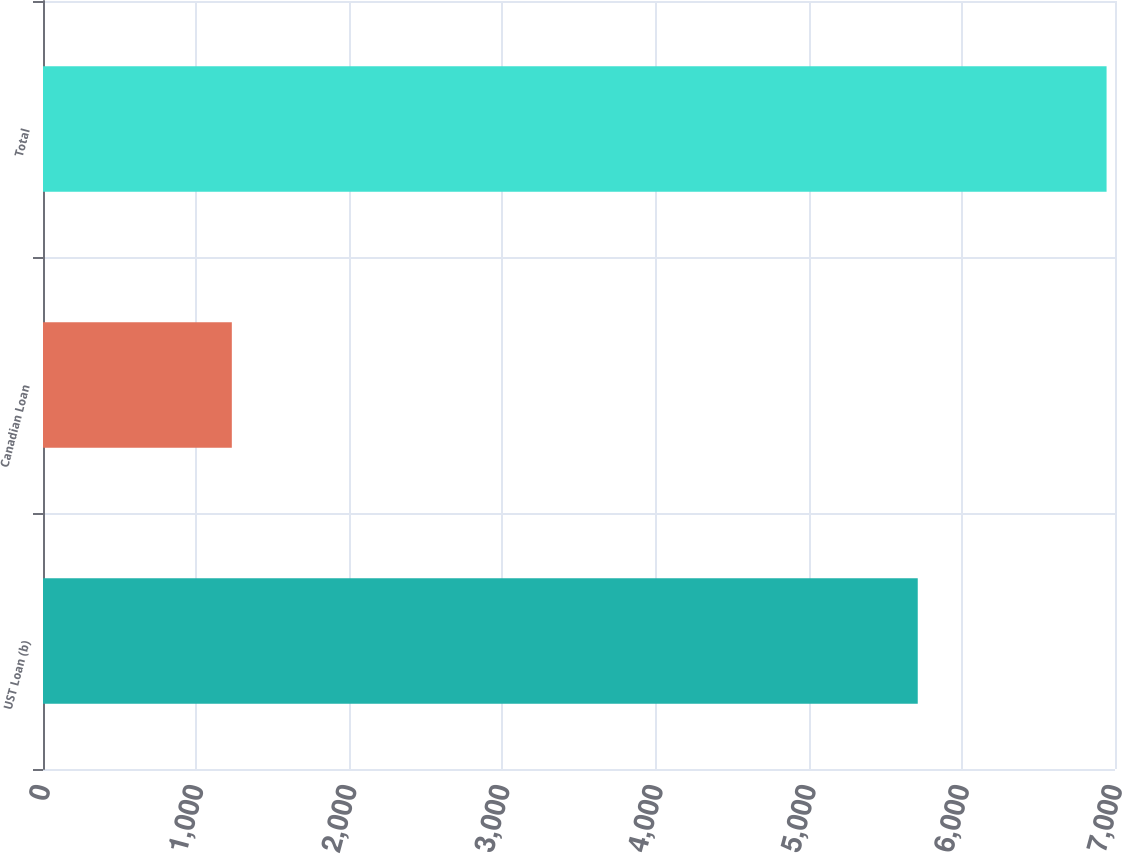<chart> <loc_0><loc_0><loc_500><loc_500><bar_chart><fcel>UST Loan (b)<fcel>Canadian Loan<fcel>Total<nl><fcel>5712<fcel>1233<fcel>6945<nl></chart> 